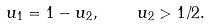Convert formula to latex. <formula><loc_0><loc_0><loc_500><loc_500>u _ { 1 } = 1 - u _ { 2 } , \quad u _ { 2 } > 1 / 2 .</formula> 